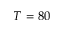<formula> <loc_0><loc_0><loc_500><loc_500>T = 8 0</formula> 